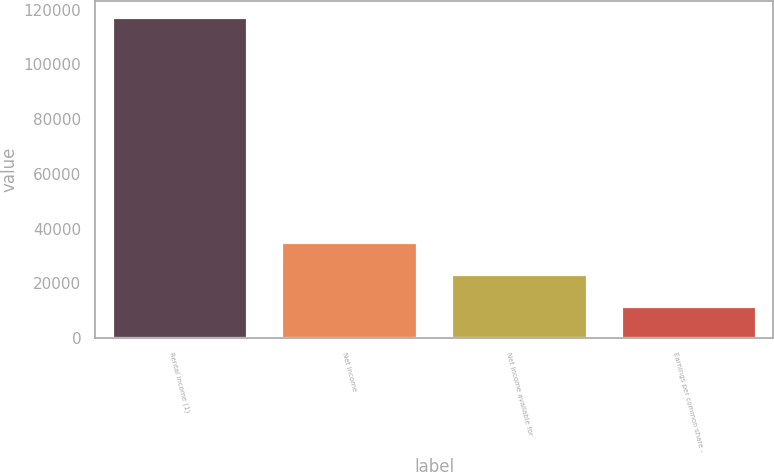Convert chart to OTSL. <chart><loc_0><loc_0><loc_500><loc_500><bar_chart><fcel>Rental income (1)<fcel>Net income<fcel>Net income available for<fcel>Earnings per common share -<nl><fcel>117193<fcel>35158.1<fcel>23438.9<fcel>11719.6<nl></chart> 